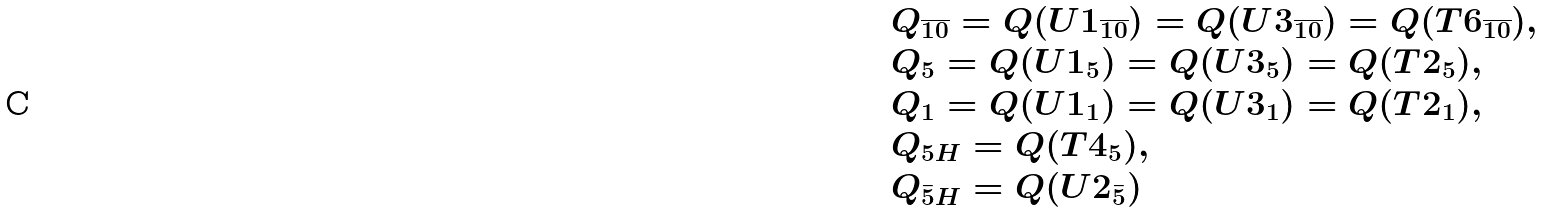<formula> <loc_0><loc_0><loc_500><loc_500>\begin{array} { l } Q _ { \overline { 1 0 } } = Q ( U 1 _ { \overline { 1 0 } } ) = Q ( U 3 _ { \overline { 1 0 } } ) = Q ( T 6 _ { \overline { 1 0 } } ) , \\ Q _ { 5 } = Q ( U 1 _ { 5 } ) = Q ( U 3 _ { 5 } ) = Q ( T 2 _ { 5 } ) , \\ Q _ { 1 } = Q ( U 1 _ { 1 } ) = Q ( U 3 _ { 1 } ) = Q ( T 2 _ { 1 } ) , \\ Q _ { 5 H } = Q ( T 4 _ { 5 } ) , \\ Q _ { \bar { 5 } H } = Q ( U 2 _ { \bar { 5 } } ) \end{array}</formula> 